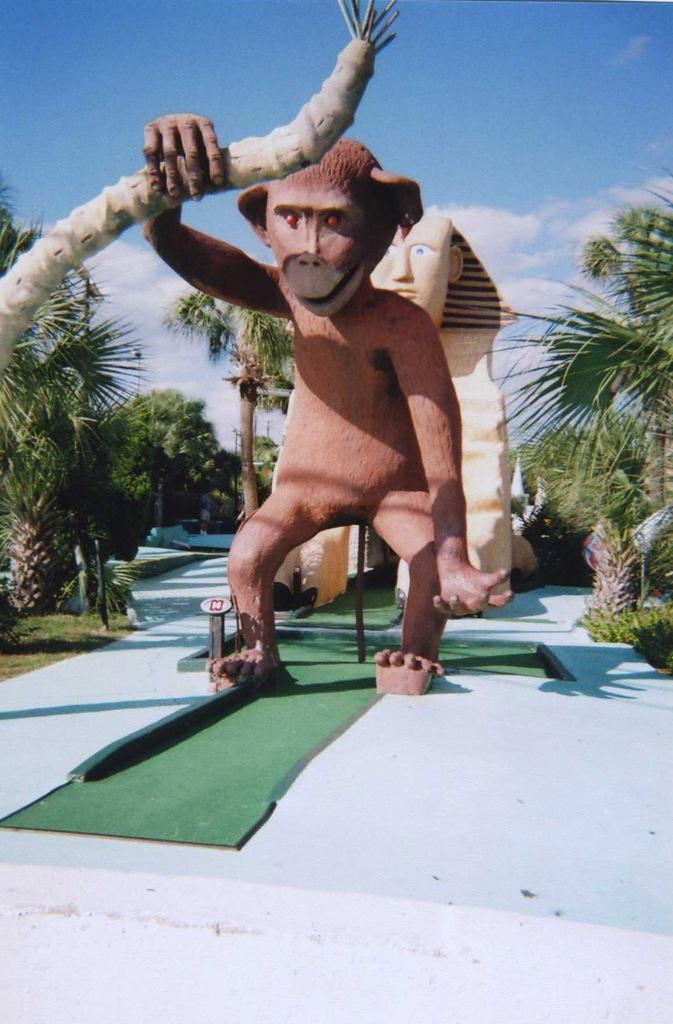What animal is depicted in the image? There is a depiction of a monkey in the image. What can be seen in the foreground of the image? There is a path visible in the image. What type of vegetation is present in the image? There are trees in the image. What is visible in the background of the image? The sky is clear in the background of the image}. What type of desk can be seen in the image? There is no desk present in the image. What is the monkey's wish in the image? The image does not depict the monkey's thoughts or desires, so it is impossible to determine its wish. 